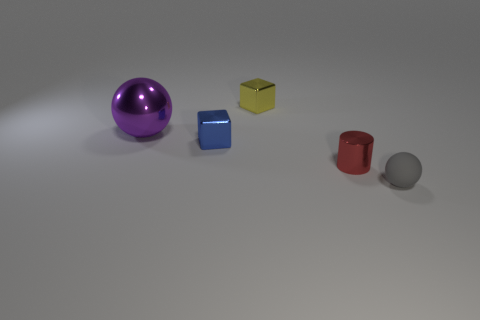How many yellow objects are either tiny blocks or large things?
Keep it short and to the point. 1. Do the red cylinder and the ball right of the tiny red metal object have the same material?
Provide a succinct answer. No. There is a purple object that is the same shape as the small gray object; what size is it?
Provide a succinct answer. Large. What material is the yellow thing?
Offer a very short reply. Metal. There is a sphere on the right side of the tiny blue block on the right side of the ball that is behind the tiny rubber object; what is its material?
Offer a very short reply. Rubber. Is the size of the metal thing that is behind the purple metallic ball the same as the sphere that is to the left of the gray matte thing?
Provide a short and direct response. No. What number of other things are there of the same material as the small red cylinder
Your response must be concise. 3. What number of matte things are either blue cubes or large purple balls?
Your response must be concise. 0. Is the number of tiny gray matte objects less than the number of tiny purple blocks?
Provide a succinct answer. No. There is a blue shiny block; is it the same size as the sphere right of the red shiny cylinder?
Your response must be concise. Yes. 